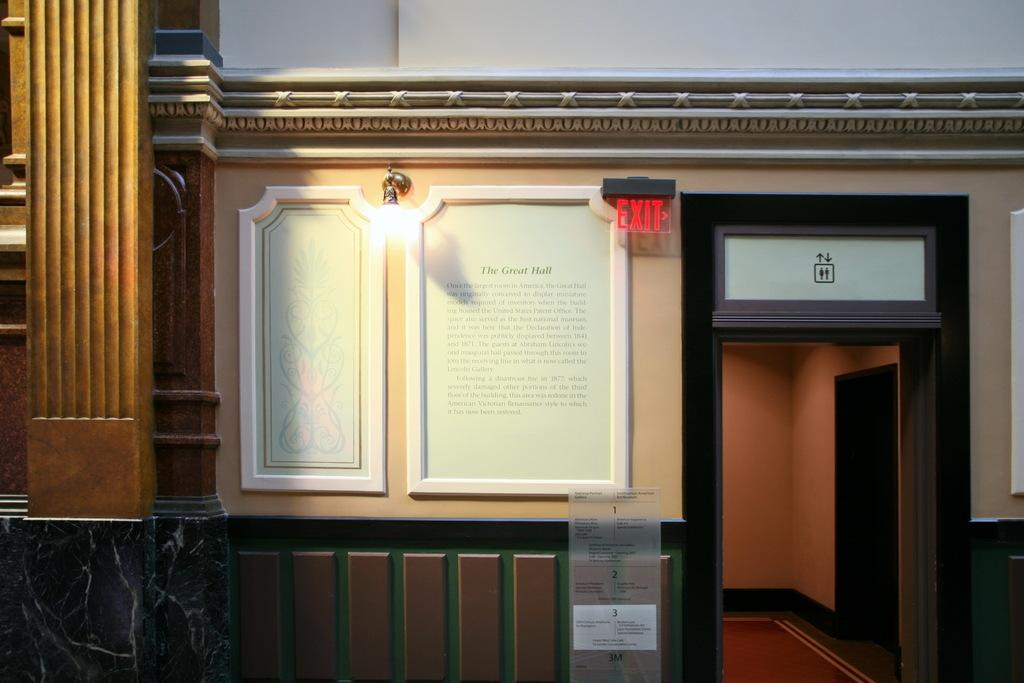What type of structure is present in the image? There is a building in the image. What is attached to the building wall? There is a notice board and a light visible on the building wall. What other signage can be seen in the image? There is a sign board visible in the image. What type of creature can be seen living inside the building in the image? There is no creature visible inside the building in the image. What store is located on the ground floor of the building? The provided facts do not mention any store or room inside the building, so we cannot answer this question. 